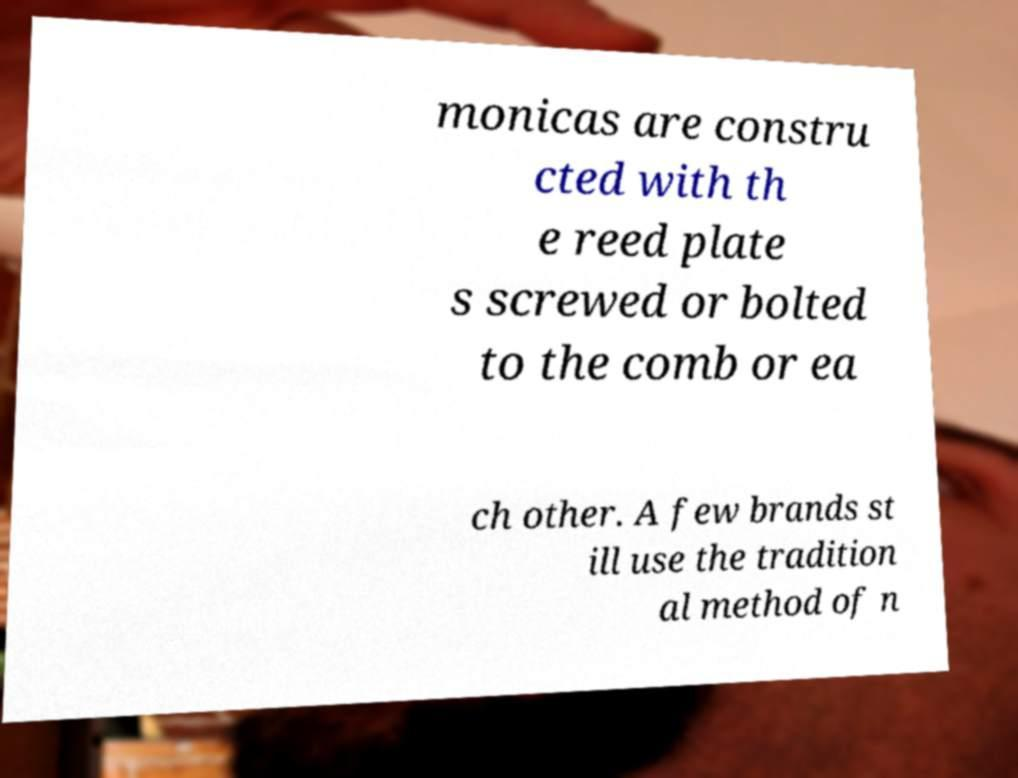Could you assist in decoding the text presented in this image and type it out clearly? monicas are constru cted with th e reed plate s screwed or bolted to the comb or ea ch other. A few brands st ill use the tradition al method of n 